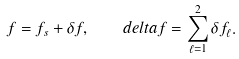<formula> <loc_0><loc_0><loc_500><loc_500>f = f _ { s } + \delta f , \quad d e l t a f = \sum _ { \ell = 1 } ^ { 2 } \delta f _ { \ell } .</formula> 